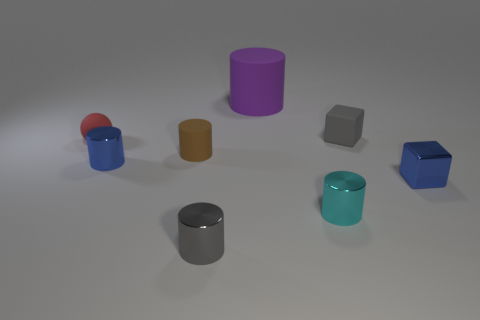Subtract all blue shiny cylinders. How many cylinders are left? 4 Subtract 2 cylinders. How many cylinders are left? 3 Subtract all purple cylinders. How many cylinders are left? 4 Subtract all yellow cylinders. Subtract all red blocks. How many cylinders are left? 5 Add 1 big blue shiny cylinders. How many objects exist? 9 Subtract all cylinders. How many objects are left? 3 Subtract all tiny yellow matte cylinders. Subtract all small gray matte objects. How many objects are left? 7 Add 2 cylinders. How many cylinders are left? 7 Add 5 yellow blocks. How many yellow blocks exist? 5 Subtract 1 purple cylinders. How many objects are left? 7 